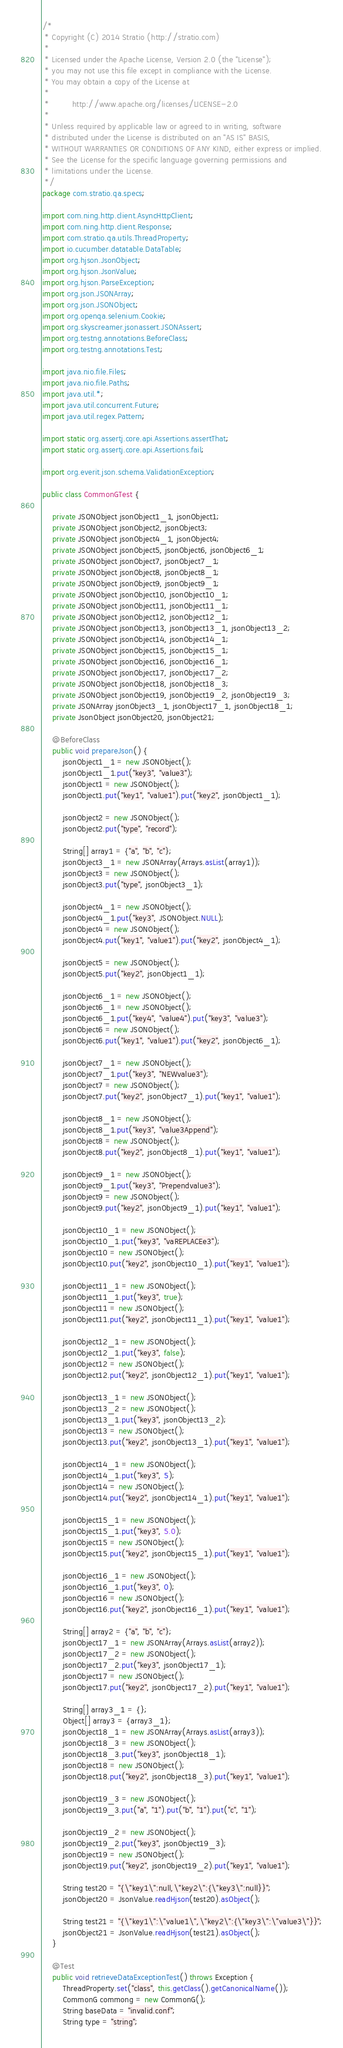<code> <loc_0><loc_0><loc_500><loc_500><_Java_>/*
 * Copyright (C) 2014 Stratio (http://stratio.com)
 *
 * Licensed under the Apache License, Version 2.0 (the "License");
 * you may not use this file except in compliance with the License.
 * You may obtain a copy of the License at
 *
 *         http://www.apache.org/licenses/LICENSE-2.0
 *
 * Unless required by applicable law or agreed to in writing, software
 * distributed under the License is distributed on an "AS IS" BASIS,
 * WITHOUT WARRANTIES OR CONDITIONS OF ANY KIND, either express or implied.
 * See the License for the specific language governing permissions and
 * limitations under the License.
 */
package com.stratio.qa.specs;

import com.ning.http.client.AsyncHttpClient;
import com.ning.http.client.Response;
import com.stratio.qa.utils.ThreadProperty;
import io.cucumber.datatable.DataTable;
import org.hjson.JsonObject;
import org.hjson.JsonValue;
import org.hjson.ParseException;
import org.json.JSONArray;
import org.json.JSONObject;
import org.openqa.selenium.Cookie;
import org.skyscreamer.jsonassert.JSONAssert;
import org.testng.annotations.BeforeClass;
import org.testng.annotations.Test;

import java.nio.file.Files;
import java.nio.file.Paths;
import java.util.*;
import java.util.concurrent.Future;
import java.util.regex.Pattern;

import static org.assertj.core.api.Assertions.assertThat;
import static org.assertj.core.api.Assertions.fail;

import org.everit.json.schema.ValidationException;

public class CommonGTest {

    private JSONObject jsonObject1_1, jsonObject1;
    private JSONObject jsonObject2, jsonObject3;
    private JSONObject jsonObject4_1, jsonObject4;
    private JSONObject jsonObject5, jsonObject6, jsonObject6_1;
    private JSONObject jsonObject7, jsonObject7_1;
    private JSONObject jsonObject8, jsonObject8_1;
    private JSONObject jsonObject9, jsonObject9_1;
    private JSONObject jsonObject10, jsonObject10_1;
    private JSONObject jsonObject11, jsonObject11_1;
    private JSONObject jsonObject12, jsonObject12_1;
    private JSONObject jsonObject13, jsonObject13_1, jsonObject13_2;
    private JSONObject jsonObject14, jsonObject14_1;
    private JSONObject jsonObject15, jsonObject15_1;
    private JSONObject jsonObject16, jsonObject16_1;
    private JSONObject jsonObject17, jsonObject17_2;
    private JSONObject jsonObject18, jsonObject18_3;
    private JSONObject jsonObject19, jsonObject19_2, jsonObject19_3;
    private JSONArray jsonObject3_1, jsonObject17_1, jsonObject18_1;
    private JsonObject jsonObject20, jsonObject21;

    @BeforeClass
    public void prepareJson() {
        jsonObject1_1 = new JSONObject();
        jsonObject1_1.put("key3", "value3");
        jsonObject1 = new JSONObject();
        jsonObject1.put("key1", "value1").put("key2", jsonObject1_1);

        jsonObject2 = new JSONObject();
        jsonObject2.put("type", "record");

        String[] array1 = {"a", "b", "c"};
        jsonObject3_1 = new JSONArray(Arrays.asList(array1));
        jsonObject3 = new JSONObject();
        jsonObject3.put("type", jsonObject3_1);

        jsonObject4_1 = new JSONObject();
        jsonObject4_1.put("key3", JSONObject.NULL);
        jsonObject4 = new JSONObject();
        jsonObject4.put("key1", "value1").put("key2", jsonObject4_1);

        jsonObject5 = new JSONObject();
        jsonObject5.put("key2", jsonObject1_1);

        jsonObject6_1 = new JSONObject();
        jsonObject6_1 = new JSONObject();
        jsonObject6_1.put("key4", "value4").put("key3", "value3");
        jsonObject6 = new JSONObject();
        jsonObject6.put("key1", "value1").put("key2", jsonObject6_1);

        jsonObject7_1 = new JSONObject();
        jsonObject7_1.put("key3", "NEWvalue3");
        jsonObject7 = new JSONObject();
        jsonObject7.put("key2", jsonObject7_1).put("key1", "value1");

        jsonObject8_1 = new JSONObject();
        jsonObject8_1.put("key3", "value3Append");
        jsonObject8 = new JSONObject();
        jsonObject8.put("key2", jsonObject8_1).put("key1", "value1");

        jsonObject9_1 = new JSONObject();
        jsonObject9_1.put("key3", "Prependvalue3");
        jsonObject9 = new JSONObject();
        jsonObject9.put("key2", jsonObject9_1).put("key1", "value1");

        jsonObject10_1 = new JSONObject();
        jsonObject10_1.put("key3", "vaREPLACEe3");
        jsonObject10 = new JSONObject();
        jsonObject10.put("key2", jsonObject10_1).put("key1", "value1");

        jsonObject11_1 = new JSONObject();
        jsonObject11_1.put("key3", true);
        jsonObject11 = new JSONObject();
        jsonObject11.put("key2", jsonObject11_1).put("key1", "value1");

        jsonObject12_1 = new JSONObject();
        jsonObject12_1.put("key3", false);
        jsonObject12 = new JSONObject();
        jsonObject12.put("key2", jsonObject12_1).put("key1", "value1");

        jsonObject13_1 = new JSONObject();
        jsonObject13_2 = new JSONObject();
        jsonObject13_1.put("key3", jsonObject13_2);
        jsonObject13 = new JSONObject();
        jsonObject13.put("key2", jsonObject13_1).put("key1", "value1");

        jsonObject14_1 = new JSONObject();
        jsonObject14_1.put("key3", 5);
        jsonObject14 = new JSONObject();
        jsonObject14.put("key2", jsonObject14_1).put("key1", "value1");

        jsonObject15_1 = new JSONObject();
        jsonObject15_1.put("key3", 5.0);
        jsonObject15 = new JSONObject();
        jsonObject15.put("key2", jsonObject15_1).put("key1", "value1");

        jsonObject16_1 = new JSONObject();
        jsonObject16_1.put("key3", 0);
        jsonObject16 = new JSONObject();
        jsonObject16.put("key2", jsonObject16_1).put("key1", "value1");

        String[] array2 = {"a", "b", "c"};
        jsonObject17_1 = new JSONArray(Arrays.asList(array2));
        jsonObject17_2 = new JSONObject();
        jsonObject17_2.put("key3", jsonObject17_1);
        jsonObject17 = new JSONObject();
        jsonObject17.put("key2", jsonObject17_2).put("key1", "value1");

        String[] array3_1 = {};
        Object[] array3 = {array3_1};
        jsonObject18_1 = new JSONArray(Arrays.asList(array3));
        jsonObject18_3 = new JSONObject();
        jsonObject18_3.put("key3", jsonObject18_1);
        jsonObject18 = new JSONObject();
        jsonObject18.put("key2", jsonObject18_3).put("key1", "value1");

        jsonObject19_3 = new JSONObject();
        jsonObject19_3.put("a", "1").put("b", "1").put("c", "1");

        jsonObject19_2 = new JSONObject();
        jsonObject19_2.put("key3", jsonObject19_3);
        jsonObject19 = new JSONObject();
        jsonObject19.put("key2", jsonObject19_2).put("key1", "value1");

        String test20 = "{\"key1\":null,\"key2\":{\"key3\":null}}";
        jsonObject20 = JsonValue.readHjson(test20).asObject();

        String test21 = "{\"key1\":\"value1\",\"key2\":{\"key3\":\"value3\"}}";
        jsonObject21 = JsonValue.readHjson(test21).asObject();
    }

    @Test
    public void retrieveDataExceptionTest() throws Exception {
        ThreadProperty.set("class", this.getClass().getCanonicalName());
        CommonG commong = new CommonG();
        String baseData = "invalid.conf";
        String type = "string";
</code> 